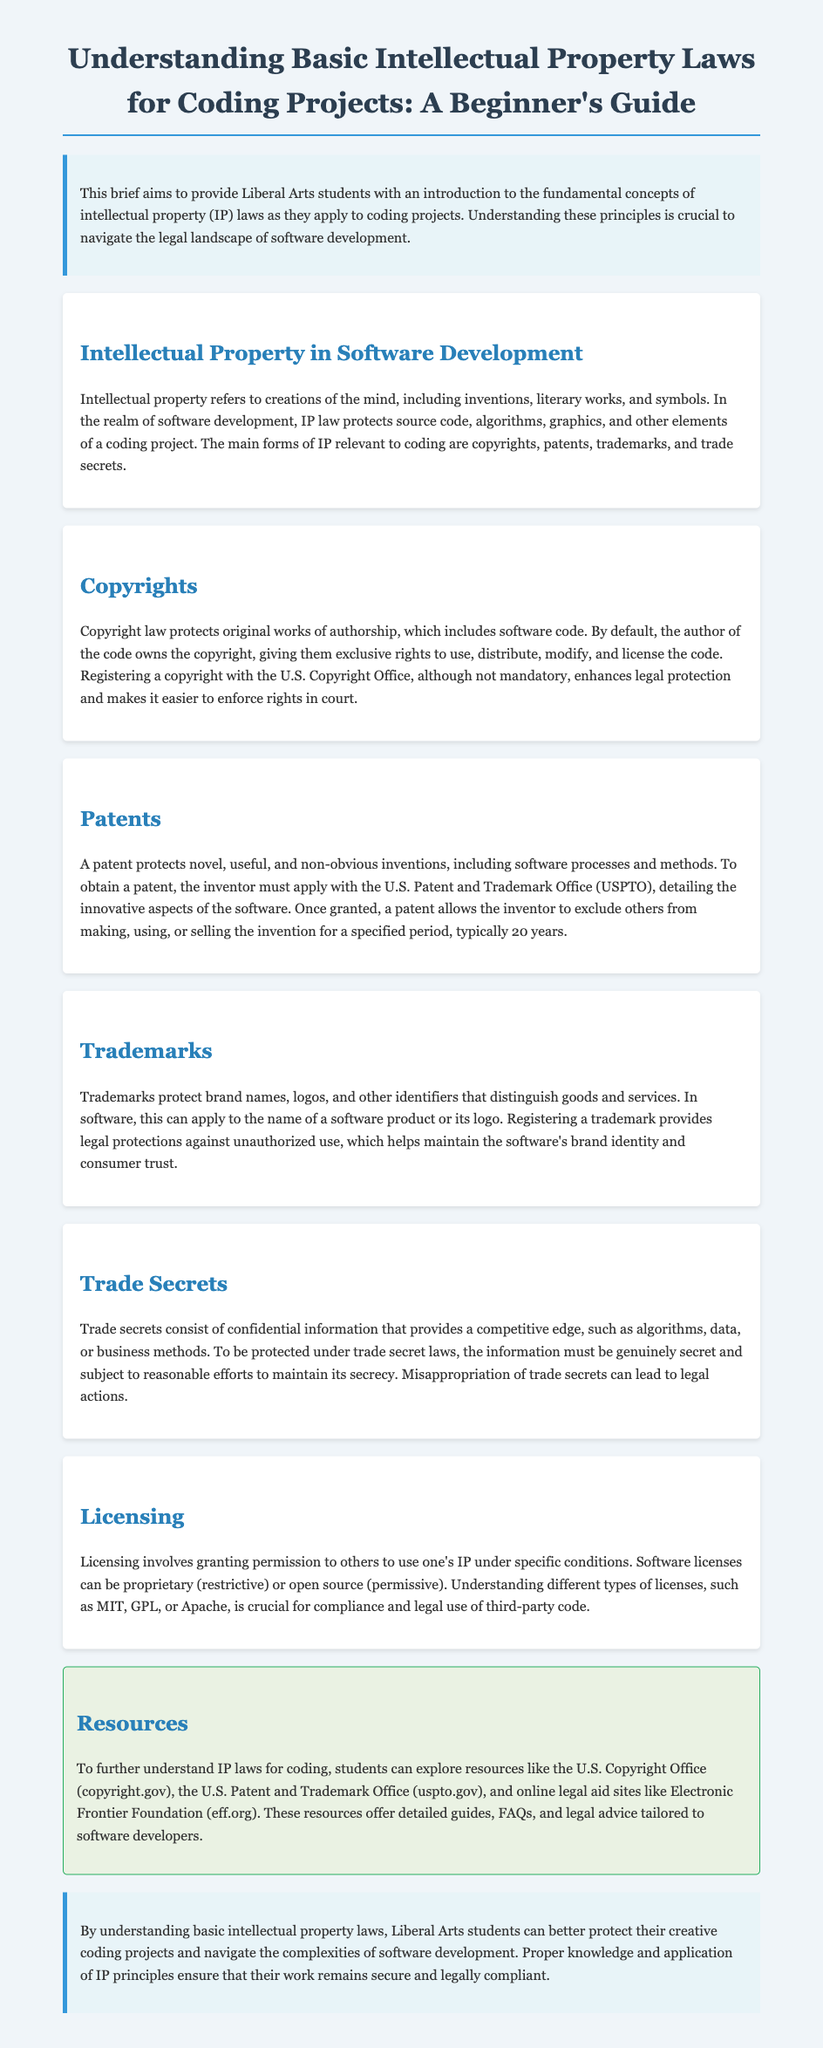what is the main purpose of this guide? The purpose of the guide is to provide an introduction to intellectual property laws for Liberal Arts students regarding coding projects.
Answer: introduction what are the main forms of IP relevant to coding? The document lists four main forms of IP relevant to coding: copyrights, patents, trademarks, and trade secrets.
Answer: copyrights, patents, trademarks, trade secrets who owns the copyright of software code by default? By default, the author of the code owns the copyright.
Answer: author how long does a patent typically last? The document states that a patent typically lasts for a specified period of 20 years.
Answer: 20 years what is the legal document for copyright registration? The legal document for copyright registration is with the U.S. Copyright Office.
Answer: U.S. Copyright Office what does a trademark protect in software? A trademark protects brand names and logos in software.
Answer: brand names, logos what are the two types of software licenses mentioned? The document mentions proprietary and open source licenses.
Answer: proprietary, open source what must trade secrets be subject to for legal protection? Trade secrets must be subject to reasonable efforts to maintain secrecy for legal protection.
Answer: reasonable efforts list one resource mentioned in the guide for understanding IP laws. One resource mentioned is the U.S. Copyright Office website.
Answer: U.S. Copyright Office 